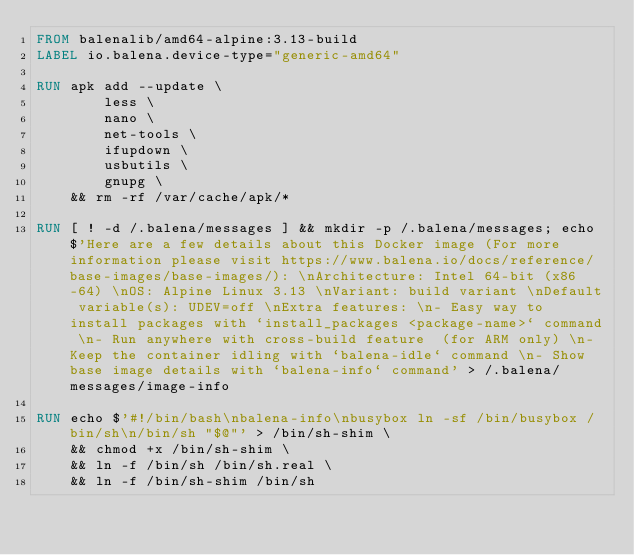<code> <loc_0><loc_0><loc_500><loc_500><_Dockerfile_>FROM balenalib/amd64-alpine:3.13-build
LABEL io.balena.device-type="generic-amd64"

RUN apk add --update \
		less \
		nano \
		net-tools \
		ifupdown \
		usbutils \
		gnupg \
	&& rm -rf /var/cache/apk/*

RUN [ ! -d /.balena/messages ] && mkdir -p /.balena/messages; echo $'Here are a few details about this Docker image (For more information please visit https://www.balena.io/docs/reference/base-images/base-images/): \nArchitecture: Intel 64-bit (x86-64) \nOS: Alpine Linux 3.13 \nVariant: build variant \nDefault variable(s): UDEV=off \nExtra features: \n- Easy way to install packages with `install_packages <package-name>` command \n- Run anywhere with cross-build feature  (for ARM only) \n- Keep the container idling with `balena-idle` command \n- Show base image details with `balena-info` command' > /.balena/messages/image-info

RUN echo $'#!/bin/bash\nbalena-info\nbusybox ln -sf /bin/busybox /bin/sh\n/bin/sh "$@"' > /bin/sh-shim \
	&& chmod +x /bin/sh-shim \
	&& ln -f /bin/sh /bin/sh.real \
	&& ln -f /bin/sh-shim /bin/sh</code> 